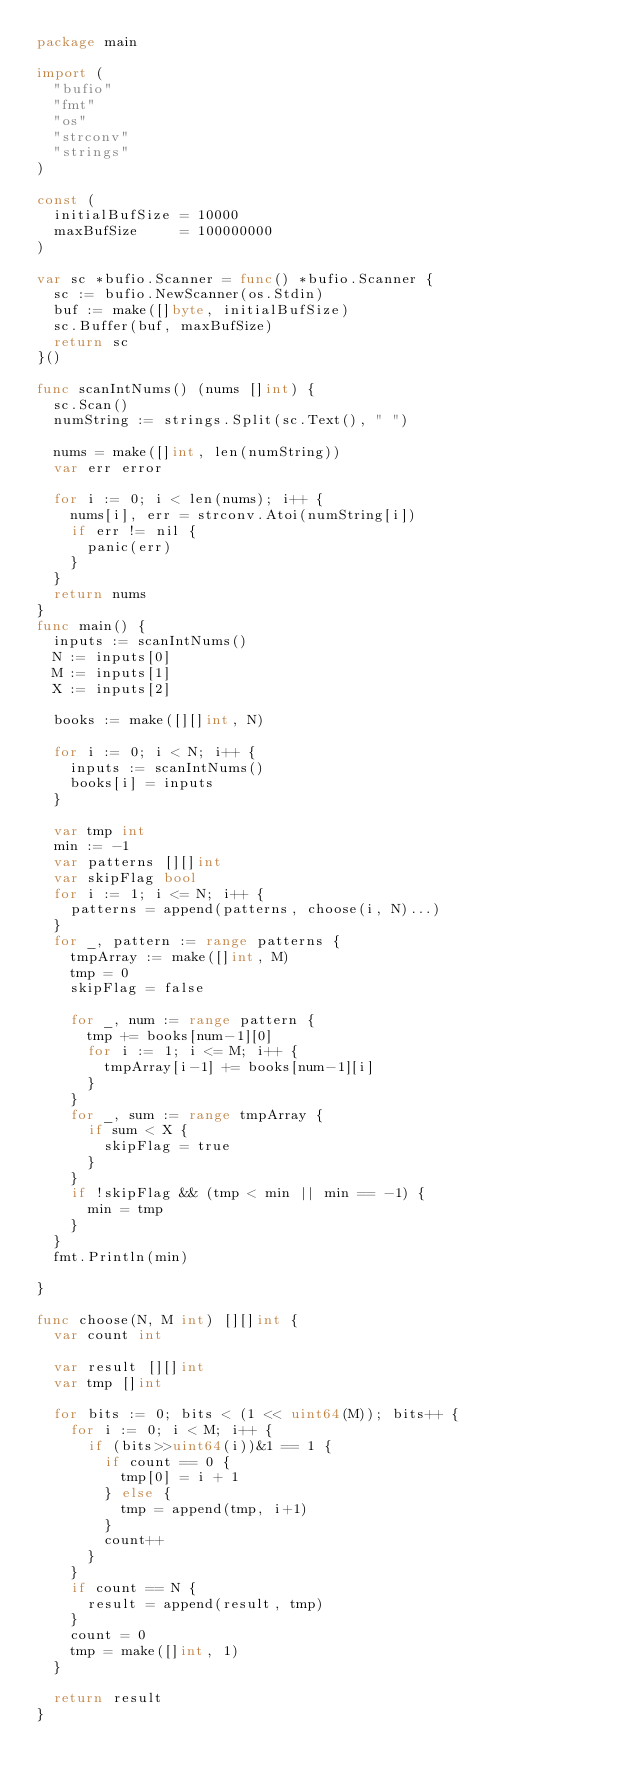Convert code to text. <code><loc_0><loc_0><loc_500><loc_500><_Go_>package main

import (
	"bufio"
	"fmt"
	"os"
	"strconv"
	"strings"
)

const (
	initialBufSize = 10000
	maxBufSize     = 100000000
)

var sc *bufio.Scanner = func() *bufio.Scanner {
	sc := bufio.NewScanner(os.Stdin)
	buf := make([]byte, initialBufSize)
	sc.Buffer(buf, maxBufSize)
	return sc
}()

func scanIntNums() (nums []int) {
	sc.Scan()
	numString := strings.Split(sc.Text(), " ")

	nums = make([]int, len(numString))
	var err error

	for i := 0; i < len(nums); i++ {
		nums[i], err = strconv.Atoi(numString[i])
		if err != nil {
			panic(err)
		}
	}
	return nums
}
func main() {
	inputs := scanIntNums()
	N := inputs[0]
	M := inputs[1]
	X := inputs[2]

	books := make([][]int, N)

	for i := 0; i < N; i++ {
		inputs := scanIntNums()
		books[i] = inputs
	}

	var tmp int
	min := -1
	var patterns [][]int
	var skipFlag bool
	for i := 1; i <= N; i++ {
		patterns = append(patterns, choose(i, N)...)
	}
	for _, pattern := range patterns {
		tmpArray := make([]int, M)
		tmp = 0
		skipFlag = false

		for _, num := range pattern {
			tmp += books[num-1][0]
			for i := 1; i <= M; i++ {
				tmpArray[i-1] += books[num-1][i]
			}
		}
		for _, sum := range tmpArray {
			if sum < X {
				skipFlag = true
			}
		}
		if !skipFlag && (tmp < min || min == -1) {
			min = tmp
		}
	}
	fmt.Println(min)

}

func choose(N, M int) [][]int {
	var count int

	var result [][]int
	var tmp []int

	for bits := 0; bits < (1 << uint64(M)); bits++ {
		for i := 0; i < M; i++ {
			if (bits>>uint64(i))&1 == 1 {
				if count == 0 {
					tmp[0] = i + 1
				} else {
					tmp = append(tmp, i+1)
				}
				count++
			}
		}
		if count == N {
			result = append(result, tmp)
		}
		count = 0
		tmp = make([]int, 1)
	}

	return result
}
</code> 